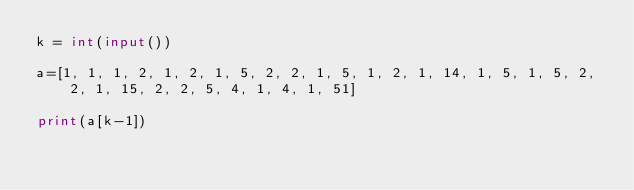<code> <loc_0><loc_0><loc_500><loc_500><_Python_>k = int(input())

a=[1, 1, 1, 2, 1, 2, 1, 5, 2, 2, 1, 5, 1, 2, 1, 14, 1, 5, 1, 5, 2, 2, 1, 15, 2, 2, 5, 4, 1, 4, 1, 51]

print(a[k-1])</code> 